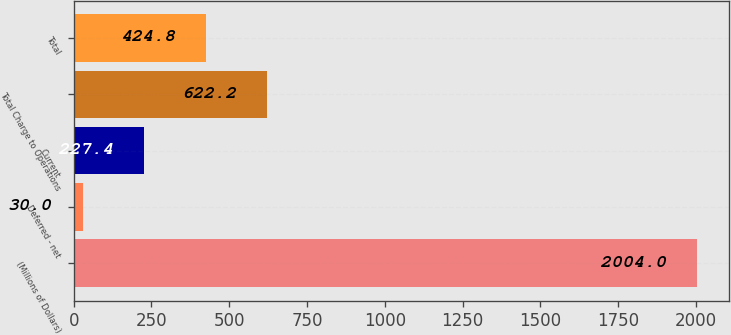Convert chart to OTSL. <chart><loc_0><loc_0><loc_500><loc_500><bar_chart><fcel>(Millions of Dollars)<fcel>Deferred - net<fcel>Current<fcel>Total Charge to Operations<fcel>Total<nl><fcel>2004<fcel>30<fcel>227.4<fcel>622.2<fcel>424.8<nl></chart> 